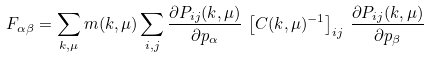<formula> <loc_0><loc_0><loc_500><loc_500>F _ { \alpha \beta } = \sum _ { k , \mu } m ( k , \mu ) \sum _ { i , j } \frac { \partial P _ { i j } ( k , \mu ) } { \partial p _ { \alpha } } \, \left [ C ( k , \mu ) ^ { - 1 } \right ] _ { i j } \, \frac { \partial P _ { i j } ( k , \mu ) } { \partial p _ { \beta } }</formula> 